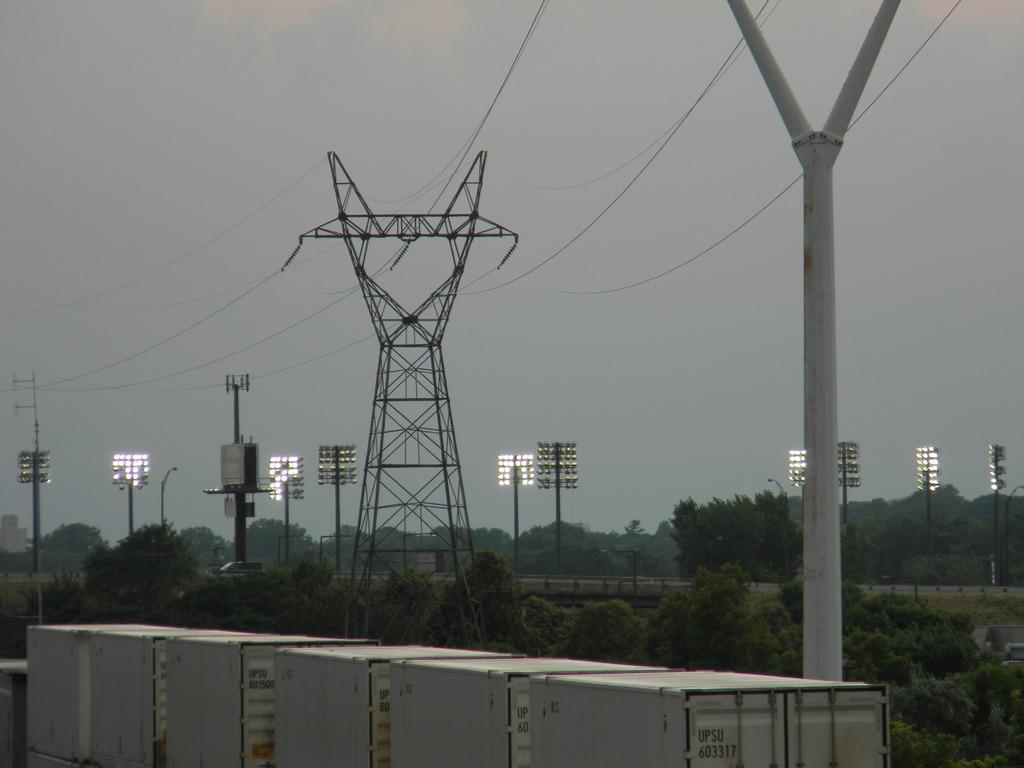In one or two sentences, can you explain what this image depicts? In this image we can see trees, poles, lights, cables and other objects. At the bottom of the image there are some containers. At the top of the image there is the sky. 